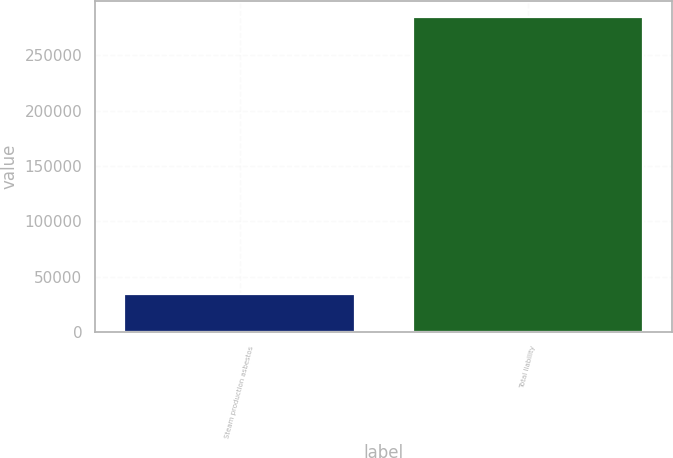<chart> <loc_0><loc_0><loc_500><loc_500><bar_chart><fcel>Steam production asbestos<fcel>Total liability<nl><fcel>33948<fcel>284990<nl></chart> 